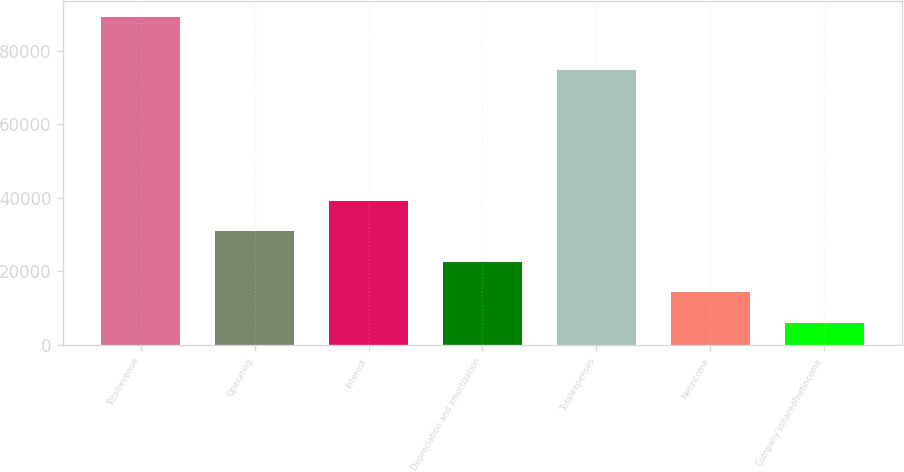Convert chart. <chart><loc_0><loc_0><loc_500><loc_500><bar_chart><fcel>Totalrevenue<fcel>Operating<fcel>Interest<fcel>Depreciation and amortization<fcel>Totalexpenses<fcel>Netincome<fcel>Company'sshareofnetincome<nl><fcel>89027<fcel>30919.3<fcel>39220.4<fcel>22618.2<fcel>74804<fcel>14317.1<fcel>6016<nl></chart> 